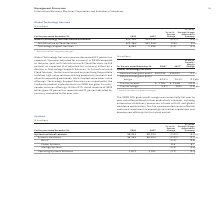According to International Business Machines's financial document, What led to fall in systems revenue from 2017 to 2018? Based on the financial document, the answer is strong IBM Z performance in 2017 and continued price pressures impacting Storage Systems in a competitive environment. Also, What factors led to growth in Power Systems  Based on the financial document, the answer is strong performance in POWER9-based systems and Linux throughout the year.. Also, How was the performance of hardware platforms year to year Based on the financial document, the answer is hardware platforms were down year to year for the full year, as reported and adjusted for currency.. Also, can you calculate: What is the increase/ (decrease) in Systems external revenue from 2017 to 2018 Based on the calculation: 8,034-8,194, the result is -160 (in millions). This is based on the information: "Systems external revenue $8,034 $8,194 (2.0)% (2.3)% Systems external revenue $8,034 $8,194 (2.0)% (2.3)%..." The key data points involved are: 8,034, 8,194. Also, can you calculate: What is the increase/ (decrease) in the value of Systems Hardware from 2017 to 2018 Based on the calculation: 6,363-6,494, the result is -131 (in millions). This is based on the information: "Systems Hardware $6,363 $6,494 (2.0)% (2.3)% Systems Hardware $6,363 $6,494 (2.0)% (2.3)%..." The key data points involved are: 6,363, 6,494. Also, can you calculate: What is the increase/ (decrease) in the value of Operating Systems Software from 2017 to 2018 Based on the calculation: 1,671-1,701, the result is -30 (in millions). This is based on the information: "Operating Systems Software 1,671 1,701 (1.7) (2.4) Operating Systems Software 1,671 1,701 (1.7) (2.4)..." The key data points involved are: 1,671, 1,701. 